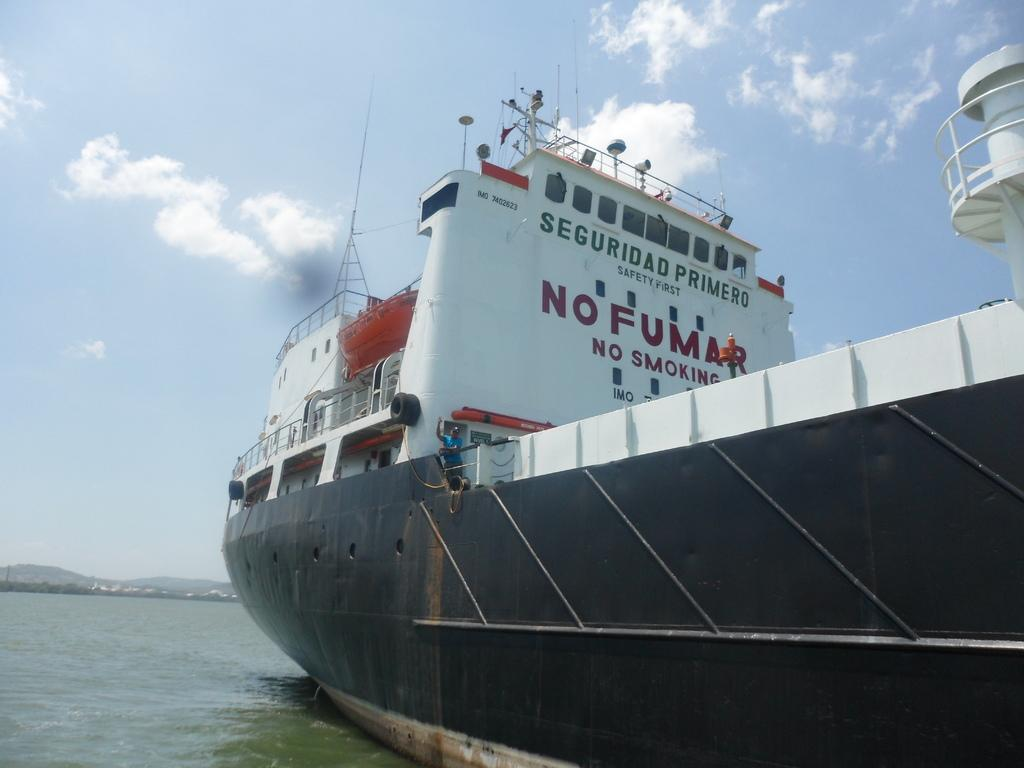What is the main subject of the image? There is a ship in the image. Where is the ship located? The ship is on the water. What can be seen at the top of the image? The sky is visible at the top of the image. What is present in the sky? Clouds are present in the sky. What can be seen in the background of the image? There are hills and trees in the background of the image. What type of party is being held on the ship in the image? There is no indication of a party in the image; it simply shows a ship on the water with clouds and hills in the background. 